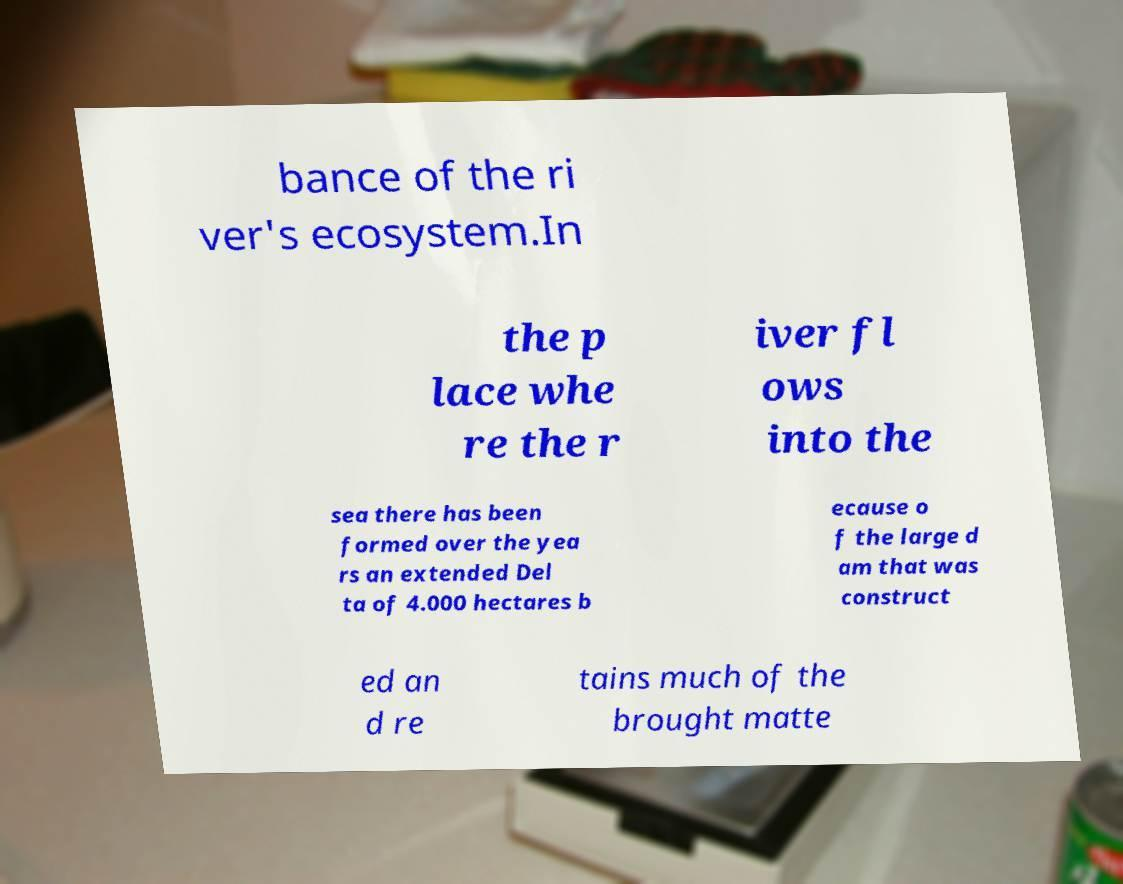I need the written content from this picture converted into text. Can you do that? bance of the ri ver's ecosystem.In the p lace whe re the r iver fl ows into the sea there has been formed over the yea rs an extended Del ta of 4.000 hectares b ecause o f the large d am that was construct ed an d re tains much of the brought matte 